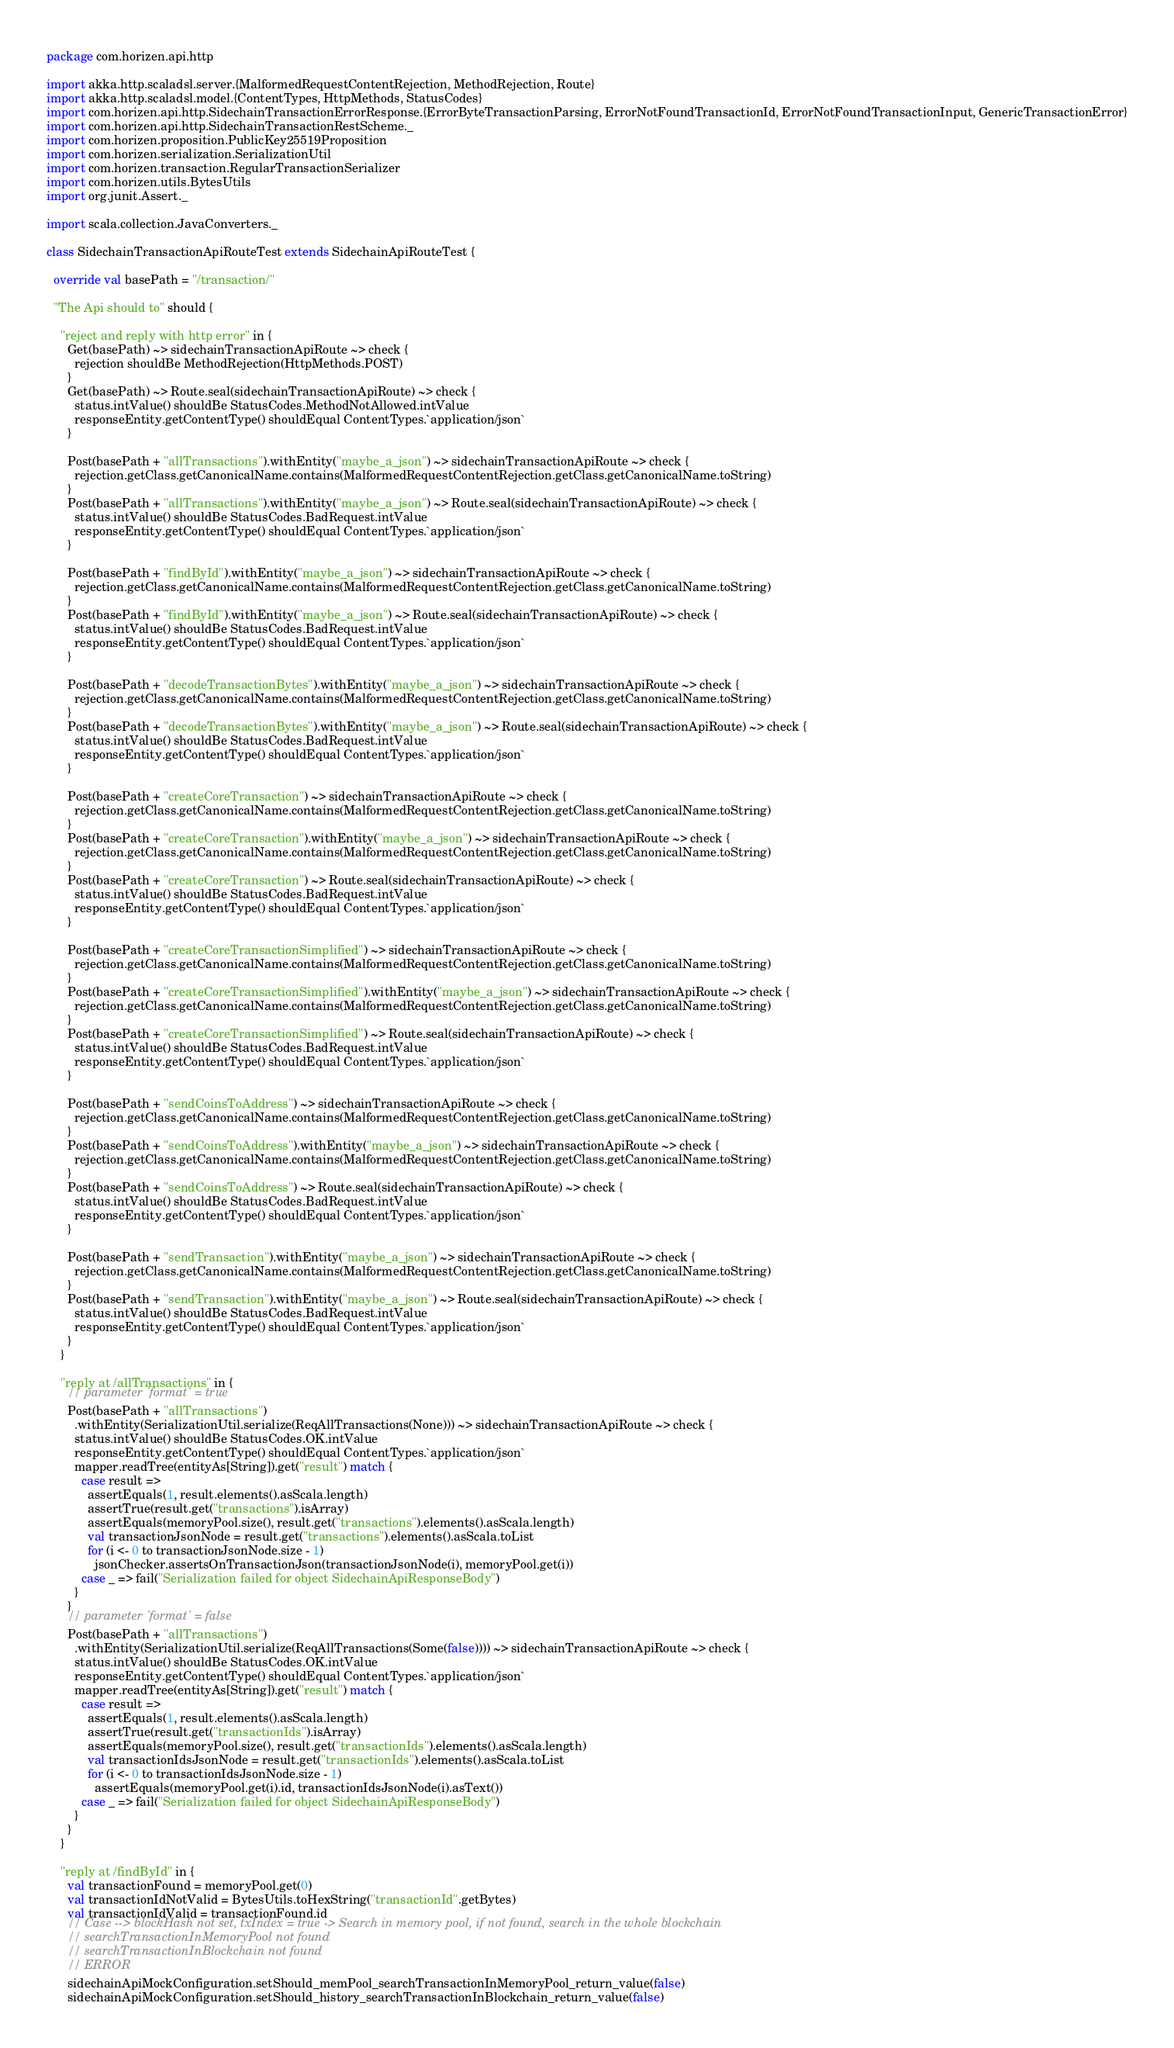<code> <loc_0><loc_0><loc_500><loc_500><_Scala_>package com.horizen.api.http

import akka.http.scaladsl.server.{MalformedRequestContentRejection, MethodRejection, Route}
import akka.http.scaladsl.model.{ContentTypes, HttpMethods, StatusCodes}
import com.horizen.api.http.SidechainTransactionErrorResponse.{ErrorByteTransactionParsing, ErrorNotFoundTransactionId, ErrorNotFoundTransactionInput, GenericTransactionError}
import com.horizen.api.http.SidechainTransactionRestScheme._
import com.horizen.proposition.PublicKey25519Proposition
import com.horizen.serialization.SerializationUtil
import com.horizen.transaction.RegularTransactionSerializer
import com.horizen.utils.BytesUtils
import org.junit.Assert._

import scala.collection.JavaConverters._

class SidechainTransactionApiRouteTest extends SidechainApiRouteTest {

  override val basePath = "/transaction/"

  "The Api should to" should {

    "reject and reply with http error" in {
      Get(basePath) ~> sidechainTransactionApiRoute ~> check {
        rejection shouldBe MethodRejection(HttpMethods.POST)
      }
      Get(basePath) ~> Route.seal(sidechainTransactionApiRoute) ~> check {
        status.intValue() shouldBe StatusCodes.MethodNotAllowed.intValue
        responseEntity.getContentType() shouldEqual ContentTypes.`application/json`
      }

      Post(basePath + "allTransactions").withEntity("maybe_a_json") ~> sidechainTransactionApiRoute ~> check {
        rejection.getClass.getCanonicalName.contains(MalformedRequestContentRejection.getClass.getCanonicalName.toString)
      }
      Post(basePath + "allTransactions").withEntity("maybe_a_json") ~> Route.seal(sidechainTransactionApiRoute) ~> check {
        status.intValue() shouldBe StatusCodes.BadRequest.intValue
        responseEntity.getContentType() shouldEqual ContentTypes.`application/json`
      }

      Post(basePath + "findById").withEntity("maybe_a_json") ~> sidechainTransactionApiRoute ~> check {
        rejection.getClass.getCanonicalName.contains(MalformedRequestContentRejection.getClass.getCanonicalName.toString)
      }
      Post(basePath + "findById").withEntity("maybe_a_json") ~> Route.seal(sidechainTransactionApiRoute) ~> check {
        status.intValue() shouldBe StatusCodes.BadRequest.intValue
        responseEntity.getContentType() shouldEqual ContentTypes.`application/json`
      }

      Post(basePath + "decodeTransactionBytes").withEntity("maybe_a_json") ~> sidechainTransactionApiRoute ~> check {
        rejection.getClass.getCanonicalName.contains(MalformedRequestContentRejection.getClass.getCanonicalName.toString)
      }
      Post(basePath + "decodeTransactionBytes").withEntity("maybe_a_json") ~> Route.seal(sidechainTransactionApiRoute) ~> check {
        status.intValue() shouldBe StatusCodes.BadRequest.intValue
        responseEntity.getContentType() shouldEqual ContentTypes.`application/json`
      }

      Post(basePath + "createCoreTransaction") ~> sidechainTransactionApiRoute ~> check {
        rejection.getClass.getCanonicalName.contains(MalformedRequestContentRejection.getClass.getCanonicalName.toString)
      }
      Post(basePath + "createCoreTransaction").withEntity("maybe_a_json") ~> sidechainTransactionApiRoute ~> check {
        rejection.getClass.getCanonicalName.contains(MalformedRequestContentRejection.getClass.getCanonicalName.toString)
      }
      Post(basePath + "createCoreTransaction") ~> Route.seal(sidechainTransactionApiRoute) ~> check {
        status.intValue() shouldBe StatusCodes.BadRequest.intValue
        responseEntity.getContentType() shouldEqual ContentTypes.`application/json`
      }

      Post(basePath + "createCoreTransactionSimplified") ~> sidechainTransactionApiRoute ~> check {
        rejection.getClass.getCanonicalName.contains(MalformedRequestContentRejection.getClass.getCanonicalName.toString)
      }
      Post(basePath + "createCoreTransactionSimplified").withEntity("maybe_a_json") ~> sidechainTransactionApiRoute ~> check {
        rejection.getClass.getCanonicalName.contains(MalformedRequestContentRejection.getClass.getCanonicalName.toString)
      }
      Post(basePath + "createCoreTransactionSimplified") ~> Route.seal(sidechainTransactionApiRoute) ~> check {
        status.intValue() shouldBe StatusCodes.BadRequest.intValue
        responseEntity.getContentType() shouldEqual ContentTypes.`application/json`
      }

      Post(basePath + "sendCoinsToAddress") ~> sidechainTransactionApiRoute ~> check {
        rejection.getClass.getCanonicalName.contains(MalformedRequestContentRejection.getClass.getCanonicalName.toString)
      }
      Post(basePath + "sendCoinsToAddress").withEntity("maybe_a_json") ~> sidechainTransactionApiRoute ~> check {
        rejection.getClass.getCanonicalName.contains(MalformedRequestContentRejection.getClass.getCanonicalName.toString)
      }
      Post(basePath + "sendCoinsToAddress") ~> Route.seal(sidechainTransactionApiRoute) ~> check {
        status.intValue() shouldBe StatusCodes.BadRequest.intValue
        responseEntity.getContentType() shouldEqual ContentTypes.`application/json`
      }

      Post(basePath + "sendTransaction").withEntity("maybe_a_json") ~> sidechainTransactionApiRoute ~> check {
        rejection.getClass.getCanonicalName.contains(MalformedRequestContentRejection.getClass.getCanonicalName.toString)
      }
      Post(basePath + "sendTransaction").withEntity("maybe_a_json") ~> Route.seal(sidechainTransactionApiRoute) ~> check {
        status.intValue() shouldBe StatusCodes.BadRequest.intValue
        responseEntity.getContentType() shouldEqual ContentTypes.`application/json`
      }
    }

    "reply at /allTransactions" in {
      // parameter 'format' = true
      Post(basePath + "allTransactions")
        .withEntity(SerializationUtil.serialize(ReqAllTransactions(None))) ~> sidechainTransactionApiRoute ~> check {
        status.intValue() shouldBe StatusCodes.OK.intValue
        responseEntity.getContentType() shouldEqual ContentTypes.`application/json`
        mapper.readTree(entityAs[String]).get("result") match {
          case result =>
            assertEquals(1, result.elements().asScala.length)
            assertTrue(result.get("transactions").isArray)
            assertEquals(memoryPool.size(), result.get("transactions").elements().asScala.length)
            val transactionJsonNode = result.get("transactions").elements().asScala.toList
            for (i <- 0 to transactionJsonNode.size - 1)
              jsonChecker.assertsOnTransactionJson(transactionJsonNode(i), memoryPool.get(i))
          case _ => fail("Serialization failed for object SidechainApiResponseBody")
        }
      }
      // parameter 'format' = false
      Post(basePath + "allTransactions")
        .withEntity(SerializationUtil.serialize(ReqAllTransactions(Some(false)))) ~> sidechainTransactionApiRoute ~> check {
        status.intValue() shouldBe StatusCodes.OK.intValue
        responseEntity.getContentType() shouldEqual ContentTypes.`application/json`
        mapper.readTree(entityAs[String]).get("result") match {
          case result =>
            assertEquals(1, result.elements().asScala.length)
            assertTrue(result.get("transactionIds").isArray)
            assertEquals(memoryPool.size(), result.get("transactionIds").elements().asScala.length)
            val transactionIdsJsonNode = result.get("transactionIds").elements().asScala.toList
            for (i <- 0 to transactionIdsJsonNode.size - 1)
              assertEquals(memoryPool.get(i).id, transactionIdsJsonNode(i).asText())
          case _ => fail("Serialization failed for object SidechainApiResponseBody")
        }
      }
    }

    "reply at /findById" in {
      val transactionFound = memoryPool.get(0)
      val transactionIdNotValid = BytesUtils.toHexString("transactionId".getBytes)
      val transactionIdValid = transactionFound.id
      // Case --> blockHash not set, txIndex = true -> Search in memory pool, if not found, search in the whole blockchain
      // searchTransactionInMemoryPool not found
      // searchTransactionInBlockchain not found
      // ERROR
      sidechainApiMockConfiguration.setShould_memPool_searchTransactionInMemoryPool_return_value(false)
      sidechainApiMockConfiguration.setShould_history_searchTransactionInBlockchain_return_value(false)</code> 